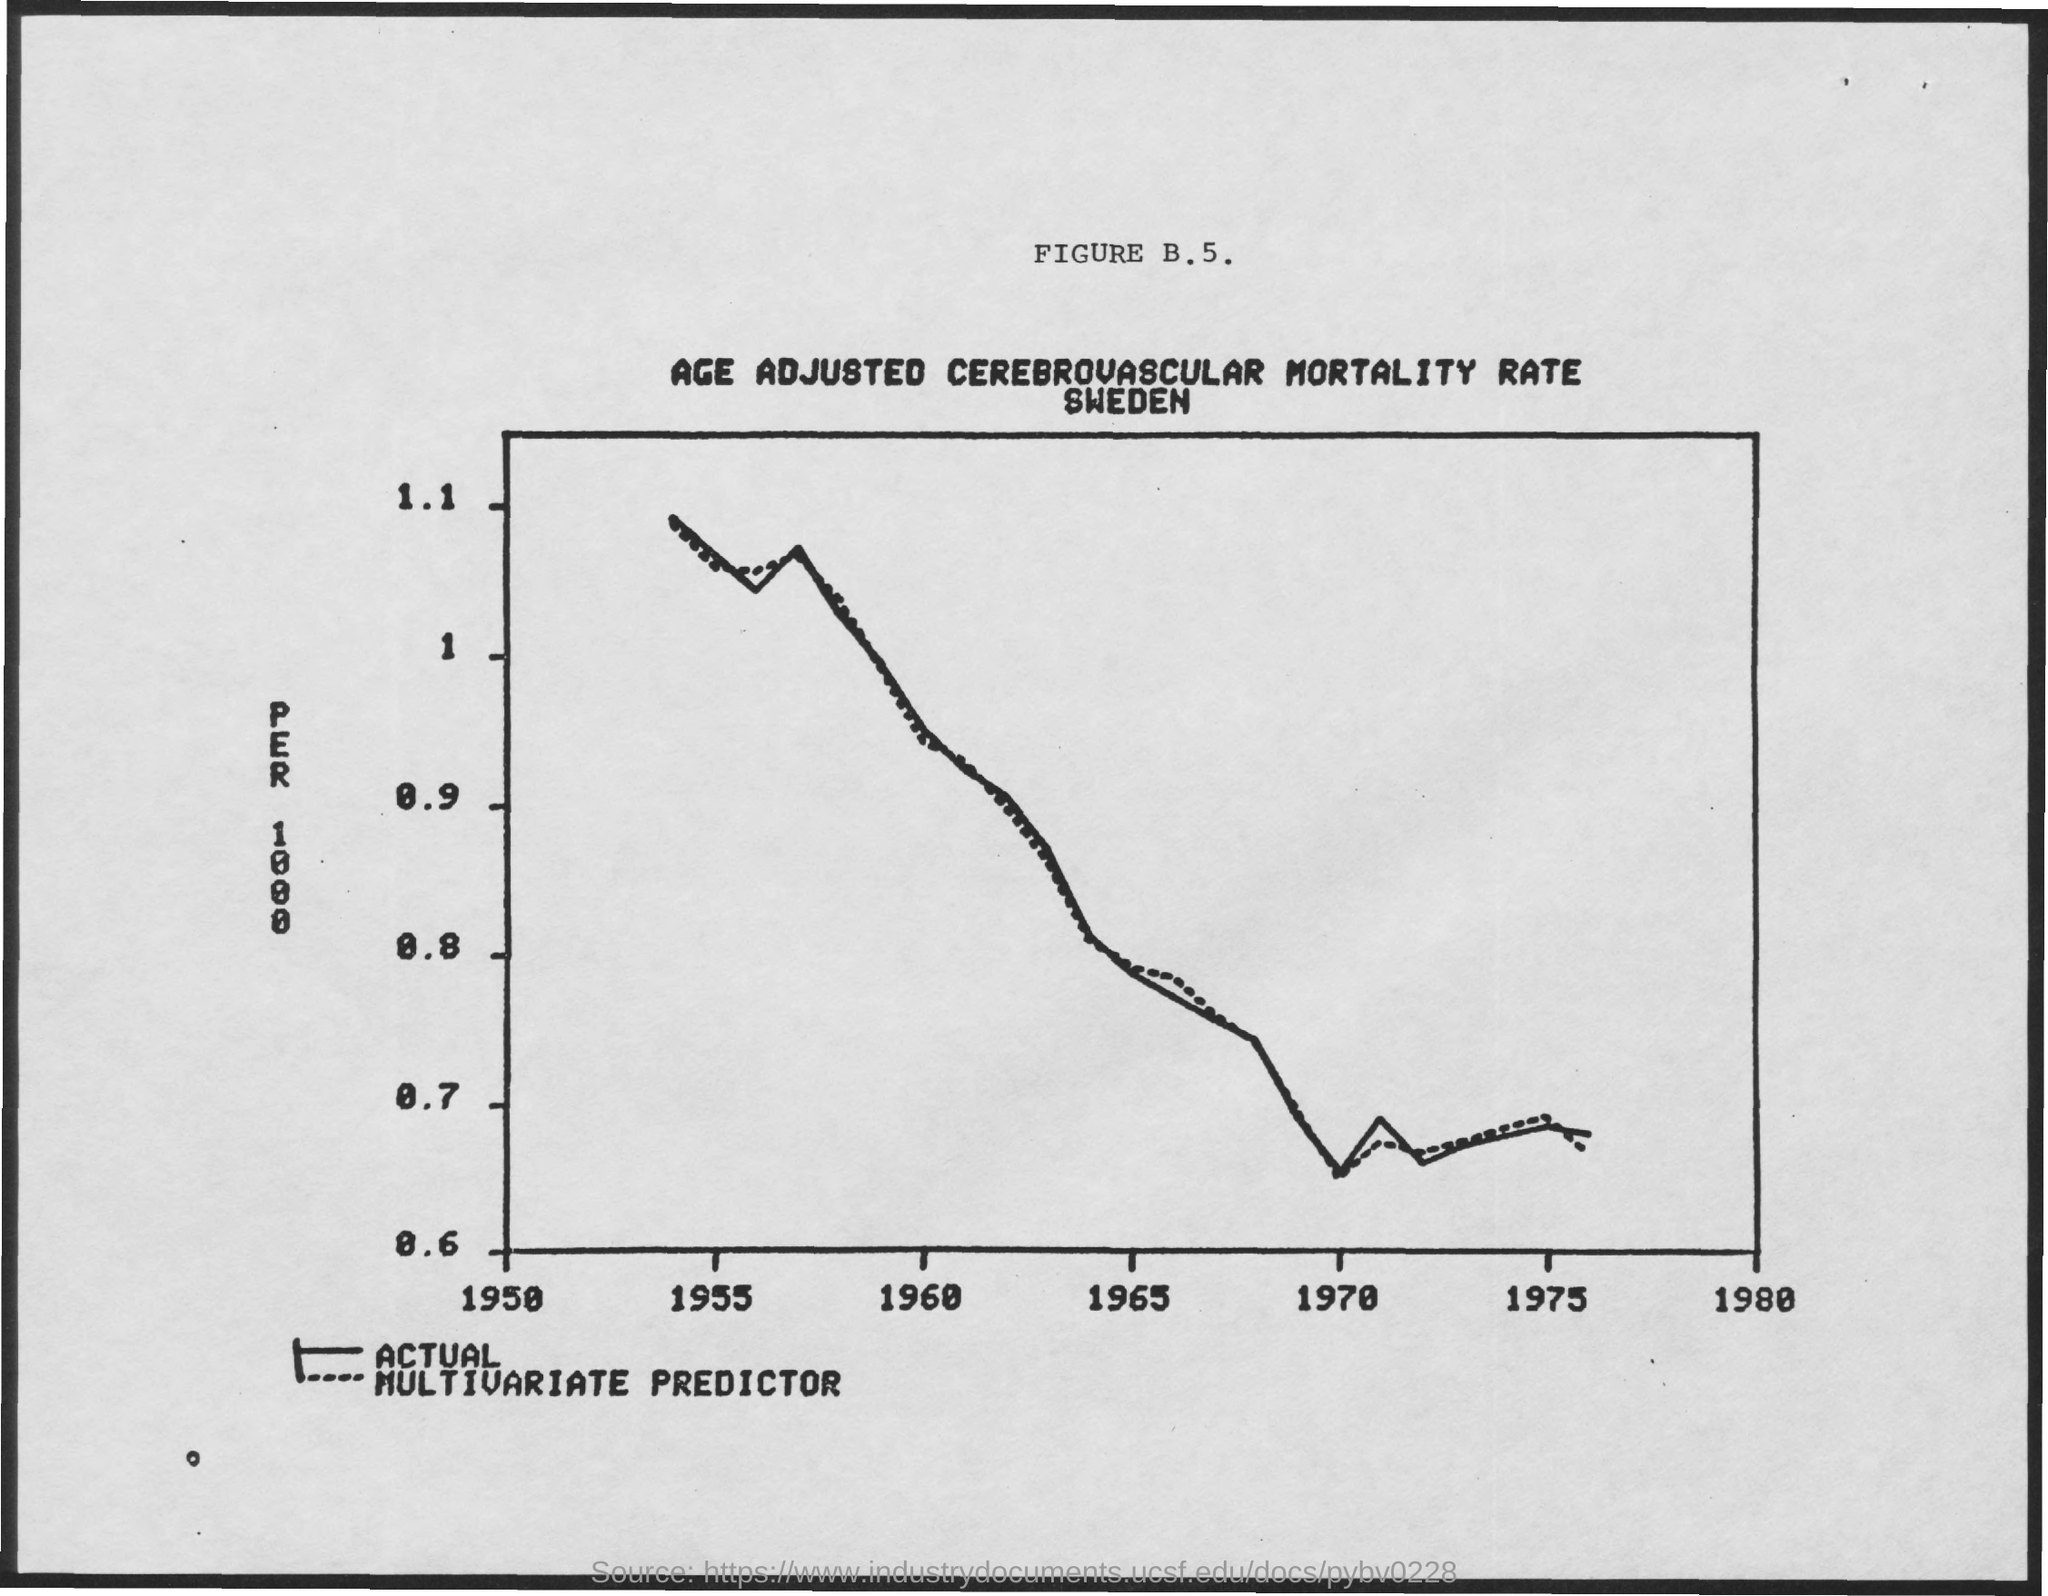Give some essential details in this illustration. This graph shows the age-adjusted cerebrovascular mortality rate in Sweden. 